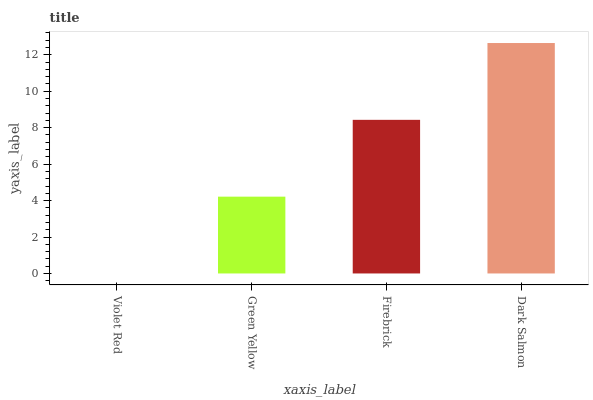Is Violet Red the minimum?
Answer yes or no. Yes. Is Dark Salmon the maximum?
Answer yes or no. Yes. Is Green Yellow the minimum?
Answer yes or no. No. Is Green Yellow the maximum?
Answer yes or no. No. Is Green Yellow greater than Violet Red?
Answer yes or no. Yes. Is Violet Red less than Green Yellow?
Answer yes or no. Yes. Is Violet Red greater than Green Yellow?
Answer yes or no. No. Is Green Yellow less than Violet Red?
Answer yes or no. No. Is Firebrick the high median?
Answer yes or no. Yes. Is Green Yellow the low median?
Answer yes or no. Yes. Is Violet Red the high median?
Answer yes or no. No. Is Violet Red the low median?
Answer yes or no. No. 